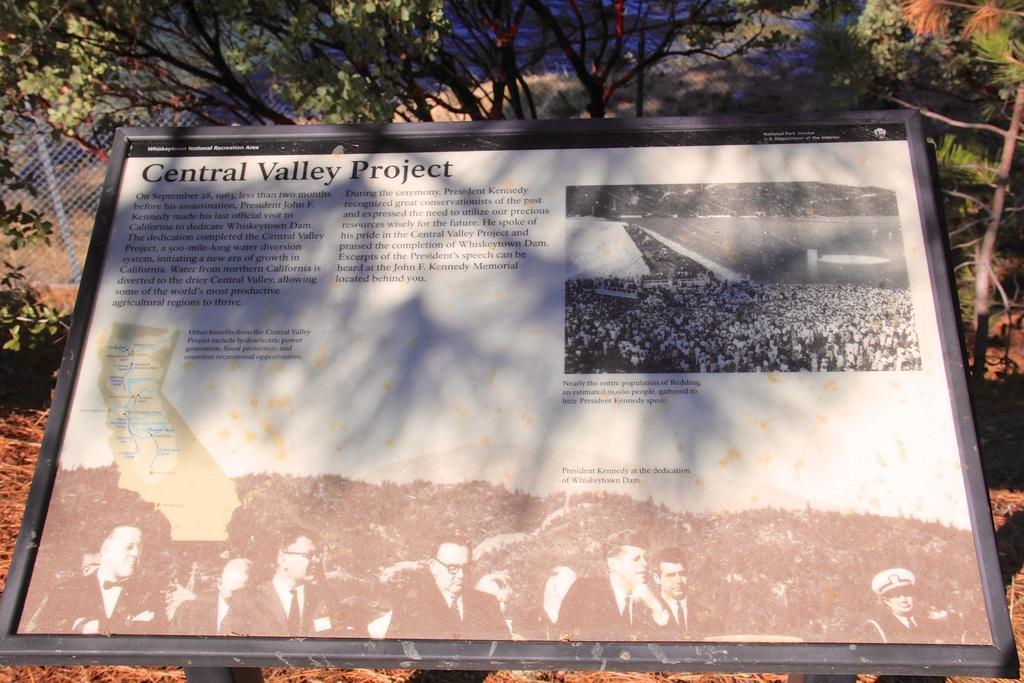How would you summarize this image in a sentence or two? There is a board, there are trees and fencing. 